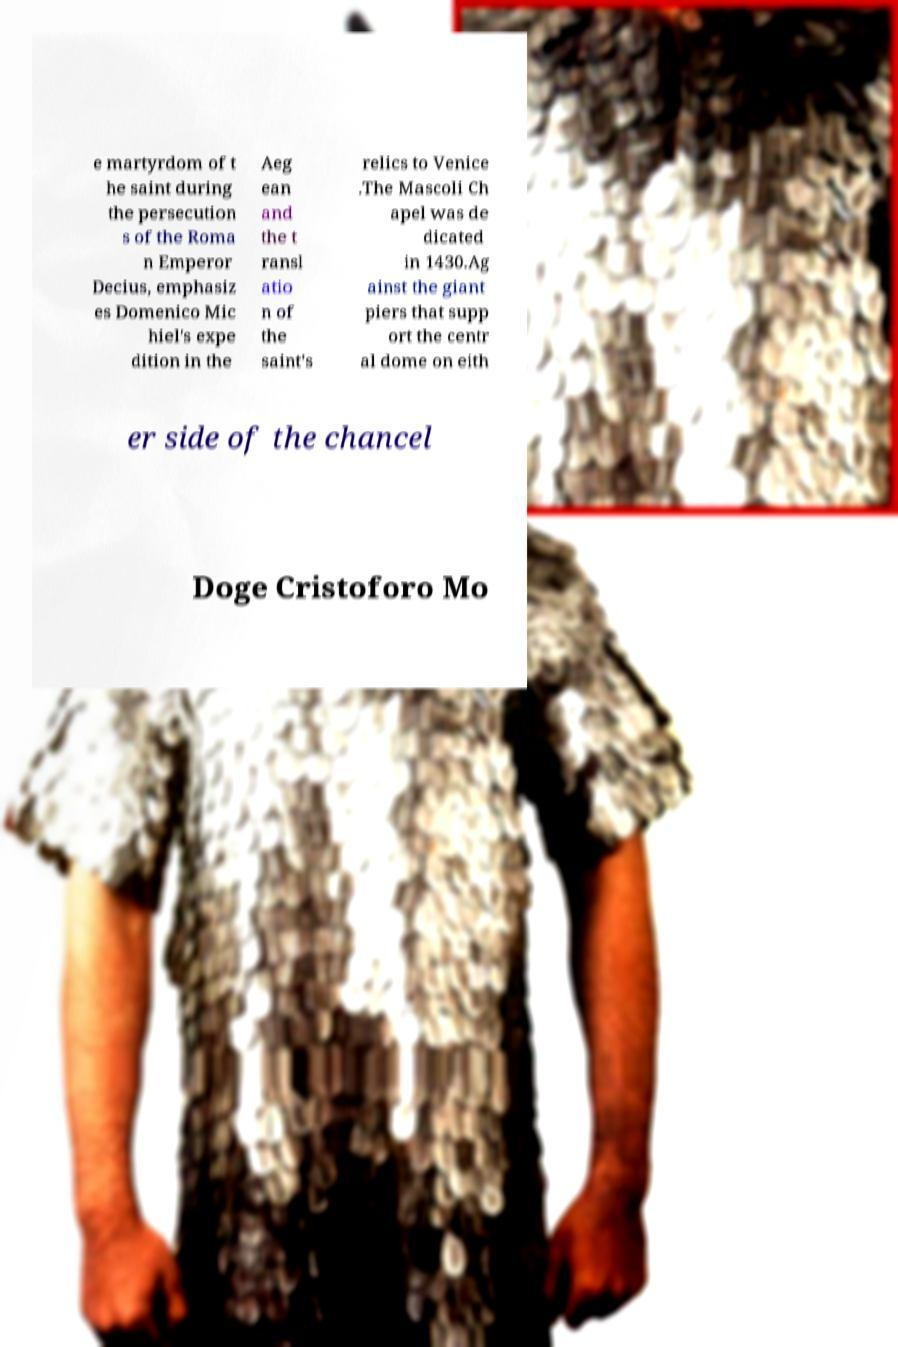Could you assist in decoding the text presented in this image and type it out clearly? e martyrdom of t he saint during the persecution s of the Roma n Emperor Decius, emphasiz es Domenico Mic hiel's expe dition in the Aeg ean and the t ransl atio n of the saint's relics to Venice .The Mascoli Ch apel was de dicated in 1430.Ag ainst the giant piers that supp ort the centr al dome on eith er side of the chancel Doge Cristoforo Mo 